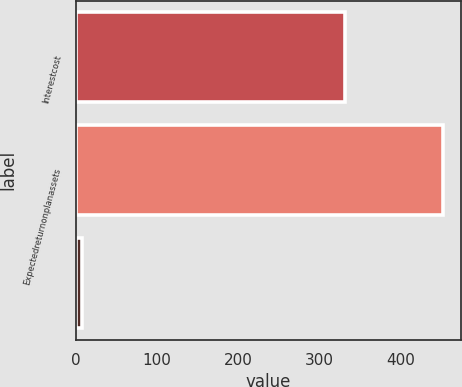Convert chart. <chart><loc_0><loc_0><loc_500><loc_500><bar_chart><fcel>Interestcost<fcel>Expectedreturnonplanassets<fcel>Unnamed: 2<nl><fcel>332<fcel>452<fcel>8<nl></chart> 